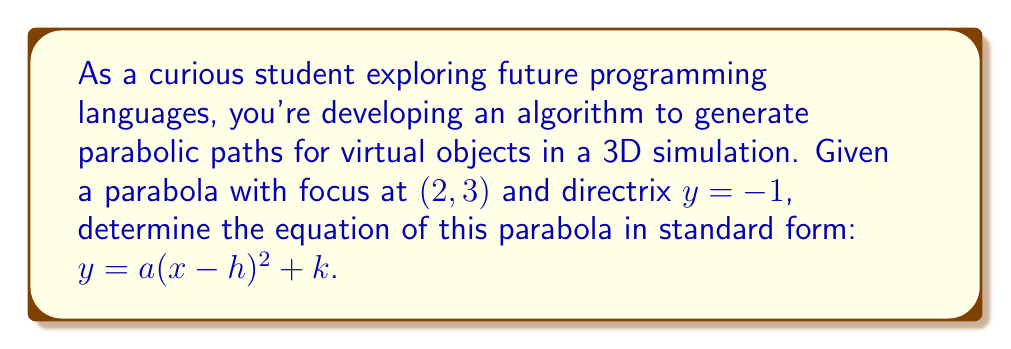Can you solve this math problem? Let's approach this step-by-step:

1) The general equation of a parabola with vertex $(h,k)$ is:
   $$y = a(x-h)^2 + k$$

2) For a parabola with a vertical axis of symmetry, the distance from any point on the parabola to the focus is equal to the distance from that point to the directrix.

3) The focus is at $(2,3)$, so $h=2$ (the x-coordinate of the vertex is the same as the x-coordinate of the focus).

4) The directrix is $y=-1$. The distance from the vertex to the directrix is:
   $$k - (-1) = k + 1$$

5) The distance from the vertex to the focus is:
   $$3 - k$$

6) These distances are equal:
   $$k + 1 = 3 - k$$

7) Solve for $k$:
   $$2k = 2$$
   $$k = 1$$

8) Now we know the vertex is at $(2,1)$.

9) To find $a$, we can use the fact that the distance from the vertex to the focus is $\frac{1}{4p}$, where $p$ is the distance from the vertex to the directrix.
   $$3 - 1 = \frac{1}{4p}$$
   $$2 = \frac{1}{4p}$$
   $$p = \frac{1}{8}$$

10) Since $a = \frac{1}{4p}$, we have:
    $$a = \frac{1}{4(\frac{1}{8})} = 2$$

11) Therefore, the equation of the parabola is:
    $$y = 2(x-2)^2 + 1$$
Answer: $y = 2(x-2)^2 + 1$ 